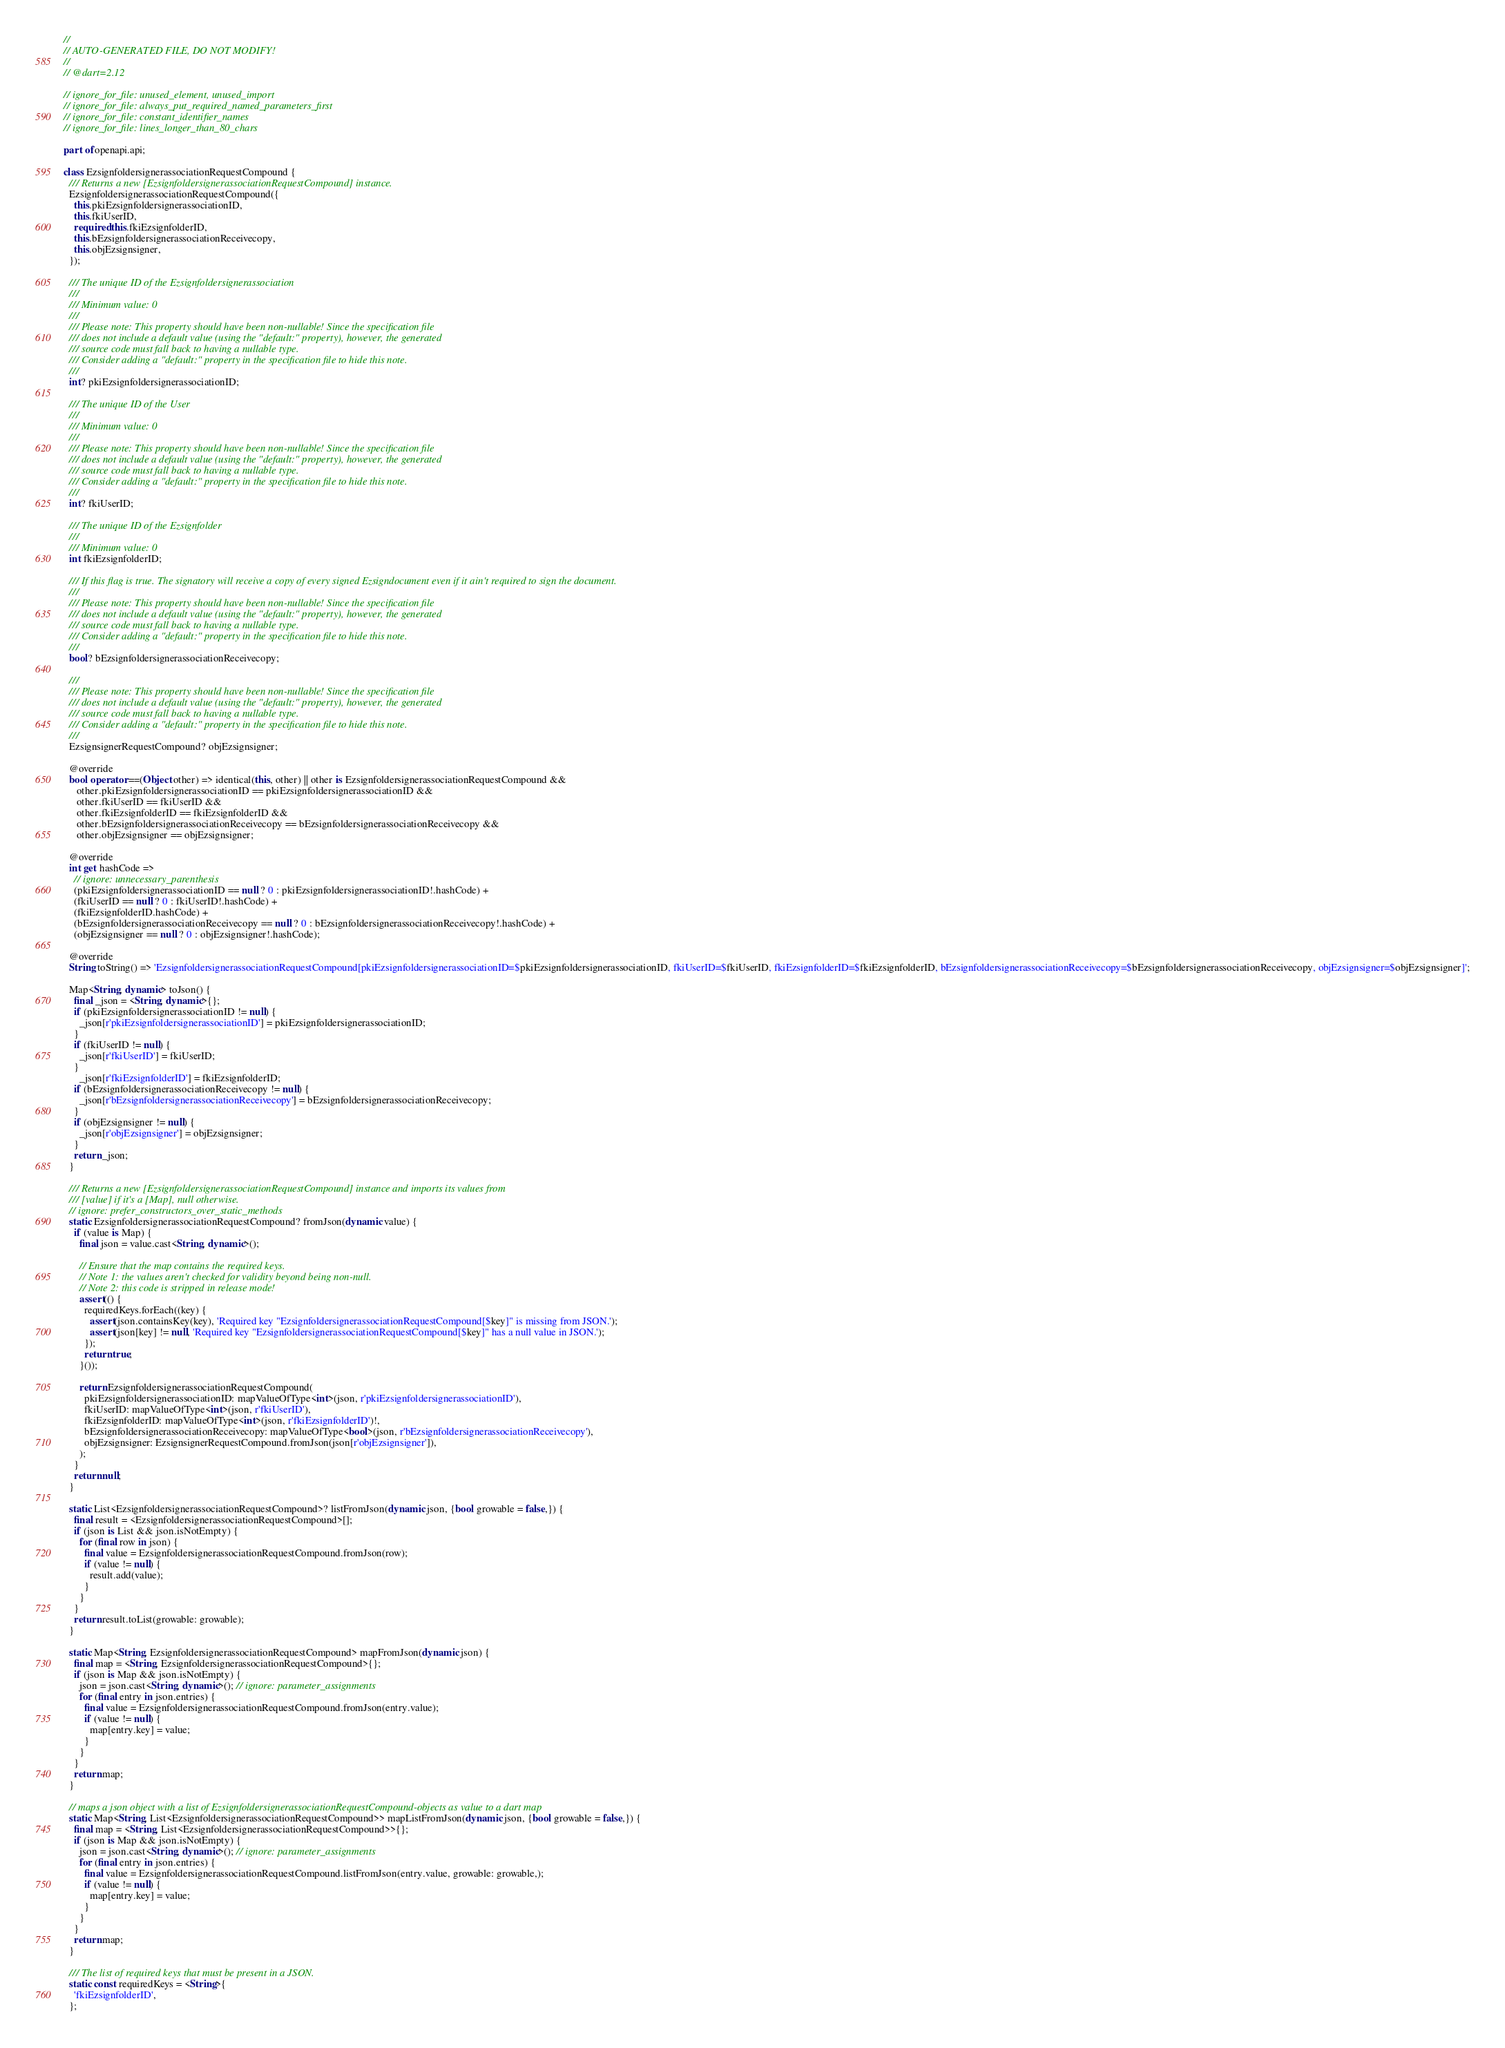Convert code to text. <code><loc_0><loc_0><loc_500><loc_500><_Dart_>//
// AUTO-GENERATED FILE, DO NOT MODIFY!
//
// @dart=2.12

// ignore_for_file: unused_element, unused_import
// ignore_for_file: always_put_required_named_parameters_first
// ignore_for_file: constant_identifier_names
// ignore_for_file: lines_longer_than_80_chars

part of openapi.api;

class EzsignfoldersignerassociationRequestCompound {
  /// Returns a new [EzsignfoldersignerassociationRequestCompound] instance.
  EzsignfoldersignerassociationRequestCompound({
    this.pkiEzsignfoldersignerassociationID,
    this.fkiUserID,
    required this.fkiEzsignfolderID,
    this.bEzsignfoldersignerassociationReceivecopy,
    this.objEzsignsigner,
  });

  /// The unique ID of the Ezsignfoldersignerassociation
  ///
  /// Minimum value: 0
  ///
  /// Please note: This property should have been non-nullable! Since the specification file
  /// does not include a default value (using the "default:" property), however, the generated
  /// source code must fall back to having a nullable type.
  /// Consider adding a "default:" property in the specification file to hide this note.
  ///
  int? pkiEzsignfoldersignerassociationID;

  /// The unique ID of the User
  ///
  /// Minimum value: 0
  ///
  /// Please note: This property should have been non-nullable! Since the specification file
  /// does not include a default value (using the "default:" property), however, the generated
  /// source code must fall back to having a nullable type.
  /// Consider adding a "default:" property in the specification file to hide this note.
  ///
  int? fkiUserID;

  /// The unique ID of the Ezsignfolder
  ///
  /// Minimum value: 0
  int fkiEzsignfolderID;

  /// If this flag is true. The signatory will receive a copy of every signed Ezsigndocument even if it ain't required to sign the document.
  ///
  /// Please note: This property should have been non-nullable! Since the specification file
  /// does not include a default value (using the "default:" property), however, the generated
  /// source code must fall back to having a nullable type.
  /// Consider adding a "default:" property in the specification file to hide this note.
  ///
  bool? bEzsignfoldersignerassociationReceivecopy;

  ///
  /// Please note: This property should have been non-nullable! Since the specification file
  /// does not include a default value (using the "default:" property), however, the generated
  /// source code must fall back to having a nullable type.
  /// Consider adding a "default:" property in the specification file to hide this note.
  ///
  EzsignsignerRequestCompound? objEzsignsigner;

  @override
  bool operator ==(Object other) => identical(this, other) || other is EzsignfoldersignerassociationRequestCompound &&
     other.pkiEzsignfoldersignerassociationID == pkiEzsignfoldersignerassociationID &&
     other.fkiUserID == fkiUserID &&
     other.fkiEzsignfolderID == fkiEzsignfolderID &&
     other.bEzsignfoldersignerassociationReceivecopy == bEzsignfoldersignerassociationReceivecopy &&
     other.objEzsignsigner == objEzsignsigner;

  @override
  int get hashCode =>
    // ignore: unnecessary_parenthesis
    (pkiEzsignfoldersignerassociationID == null ? 0 : pkiEzsignfoldersignerassociationID!.hashCode) +
    (fkiUserID == null ? 0 : fkiUserID!.hashCode) +
    (fkiEzsignfolderID.hashCode) +
    (bEzsignfoldersignerassociationReceivecopy == null ? 0 : bEzsignfoldersignerassociationReceivecopy!.hashCode) +
    (objEzsignsigner == null ? 0 : objEzsignsigner!.hashCode);

  @override
  String toString() => 'EzsignfoldersignerassociationRequestCompound[pkiEzsignfoldersignerassociationID=$pkiEzsignfoldersignerassociationID, fkiUserID=$fkiUserID, fkiEzsignfolderID=$fkiEzsignfolderID, bEzsignfoldersignerassociationReceivecopy=$bEzsignfoldersignerassociationReceivecopy, objEzsignsigner=$objEzsignsigner]';

  Map<String, dynamic> toJson() {
    final _json = <String, dynamic>{};
    if (pkiEzsignfoldersignerassociationID != null) {
      _json[r'pkiEzsignfoldersignerassociationID'] = pkiEzsignfoldersignerassociationID;
    }
    if (fkiUserID != null) {
      _json[r'fkiUserID'] = fkiUserID;
    }
      _json[r'fkiEzsignfolderID'] = fkiEzsignfolderID;
    if (bEzsignfoldersignerassociationReceivecopy != null) {
      _json[r'bEzsignfoldersignerassociationReceivecopy'] = bEzsignfoldersignerassociationReceivecopy;
    }
    if (objEzsignsigner != null) {
      _json[r'objEzsignsigner'] = objEzsignsigner;
    }
    return _json;
  }

  /// Returns a new [EzsignfoldersignerassociationRequestCompound] instance and imports its values from
  /// [value] if it's a [Map], null otherwise.
  // ignore: prefer_constructors_over_static_methods
  static EzsignfoldersignerassociationRequestCompound? fromJson(dynamic value) {
    if (value is Map) {
      final json = value.cast<String, dynamic>();

      // Ensure that the map contains the required keys.
      // Note 1: the values aren't checked for validity beyond being non-null.
      // Note 2: this code is stripped in release mode!
      assert(() {
        requiredKeys.forEach((key) {
          assert(json.containsKey(key), 'Required key "EzsignfoldersignerassociationRequestCompound[$key]" is missing from JSON.');
          assert(json[key] != null, 'Required key "EzsignfoldersignerassociationRequestCompound[$key]" has a null value in JSON.');
        });
        return true;
      }());

      return EzsignfoldersignerassociationRequestCompound(
        pkiEzsignfoldersignerassociationID: mapValueOfType<int>(json, r'pkiEzsignfoldersignerassociationID'),
        fkiUserID: mapValueOfType<int>(json, r'fkiUserID'),
        fkiEzsignfolderID: mapValueOfType<int>(json, r'fkiEzsignfolderID')!,
        bEzsignfoldersignerassociationReceivecopy: mapValueOfType<bool>(json, r'bEzsignfoldersignerassociationReceivecopy'),
        objEzsignsigner: EzsignsignerRequestCompound.fromJson(json[r'objEzsignsigner']),
      );
    }
    return null;
  }

  static List<EzsignfoldersignerassociationRequestCompound>? listFromJson(dynamic json, {bool growable = false,}) {
    final result = <EzsignfoldersignerassociationRequestCompound>[];
    if (json is List && json.isNotEmpty) {
      for (final row in json) {
        final value = EzsignfoldersignerassociationRequestCompound.fromJson(row);
        if (value != null) {
          result.add(value);
        }
      }
    }
    return result.toList(growable: growable);
  }

  static Map<String, EzsignfoldersignerassociationRequestCompound> mapFromJson(dynamic json) {
    final map = <String, EzsignfoldersignerassociationRequestCompound>{};
    if (json is Map && json.isNotEmpty) {
      json = json.cast<String, dynamic>(); // ignore: parameter_assignments
      for (final entry in json.entries) {
        final value = EzsignfoldersignerassociationRequestCompound.fromJson(entry.value);
        if (value != null) {
          map[entry.key] = value;
        }
      }
    }
    return map;
  }

  // maps a json object with a list of EzsignfoldersignerassociationRequestCompound-objects as value to a dart map
  static Map<String, List<EzsignfoldersignerassociationRequestCompound>> mapListFromJson(dynamic json, {bool growable = false,}) {
    final map = <String, List<EzsignfoldersignerassociationRequestCompound>>{};
    if (json is Map && json.isNotEmpty) {
      json = json.cast<String, dynamic>(); // ignore: parameter_assignments
      for (final entry in json.entries) {
        final value = EzsignfoldersignerassociationRequestCompound.listFromJson(entry.value, growable: growable,);
        if (value != null) {
          map[entry.key] = value;
        }
      }
    }
    return map;
  }

  /// The list of required keys that must be present in a JSON.
  static const requiredKeys = <String>{
    'fkiEzsignfolderID',
  };</code> 